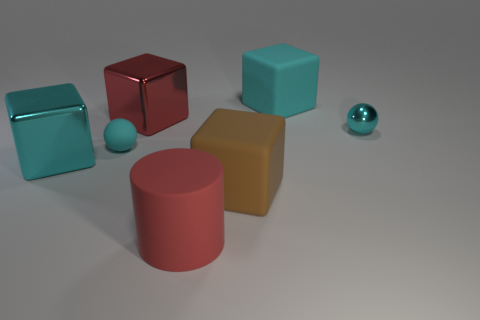Add 2 shiny objects. How many objects exist? 9 Subtract all cubes. How many objects are left? 3 Subtract all green cubes. Subtract all large red rubber objects. How many objects are left? 6 Add 4 brown objects. How many brown objects are left? 5 Add 3 metal cubes. How many metal cubes exist? 5 Subtract 0 purple cylinders. How many objects are left? 7 